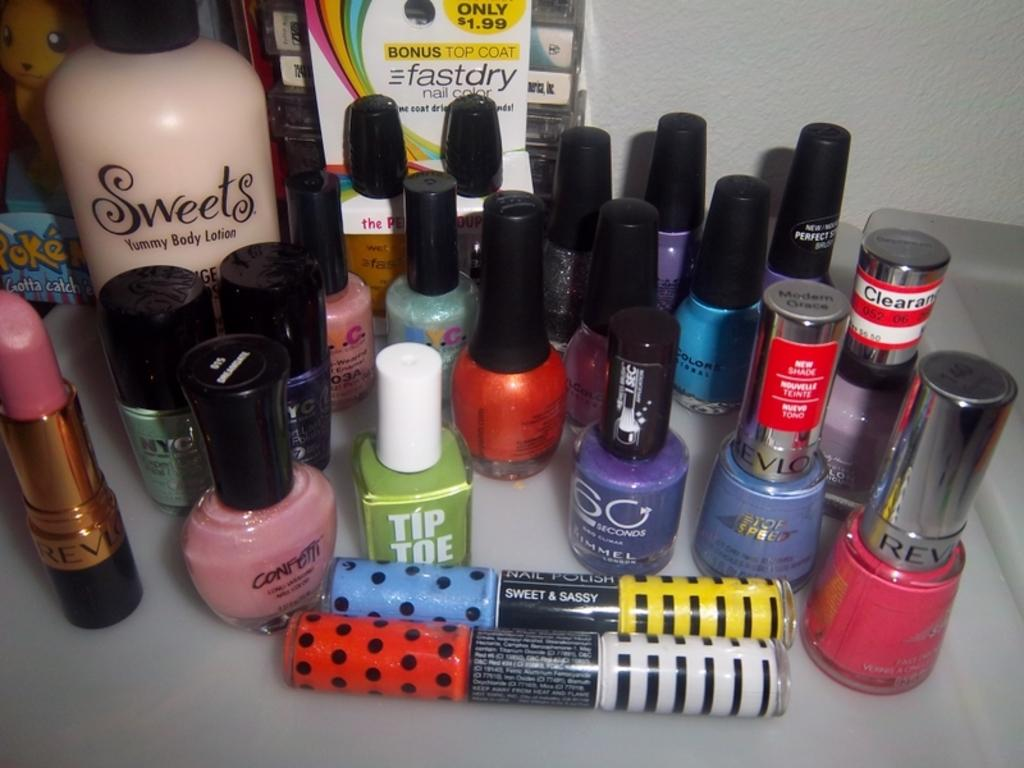<image>
Offer a succinct explanation of the picture presented. A collection of cosmetics includes a few from Revlon. 